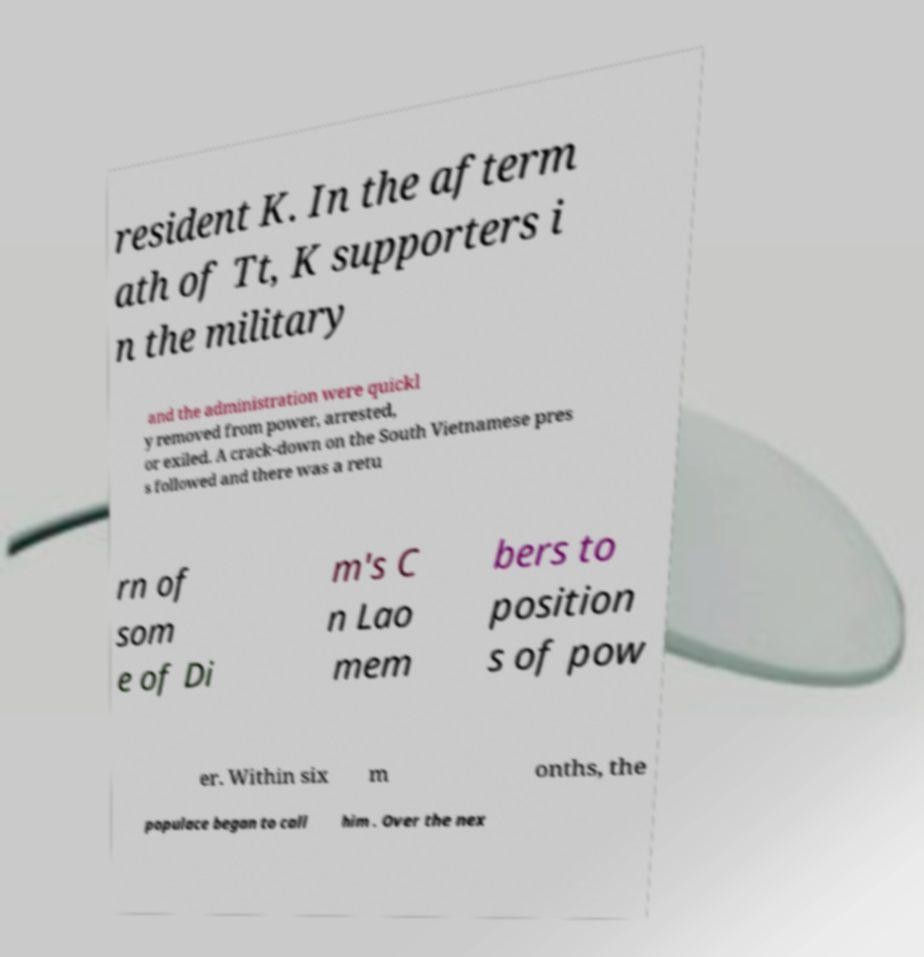Can you accurately transcribe the text from the provided image for me? resident K. In the afterm ath of Tt, K supporters i n the military and the administration were quickl y removed from power, arrested, or exiled. A crack-down on the South Vietnamese pres s followed and there was a retu rn of som e of Di m's C n Lao mem bers to position s of pow er. Within six m onths, the populace began to call him . Over the nex 